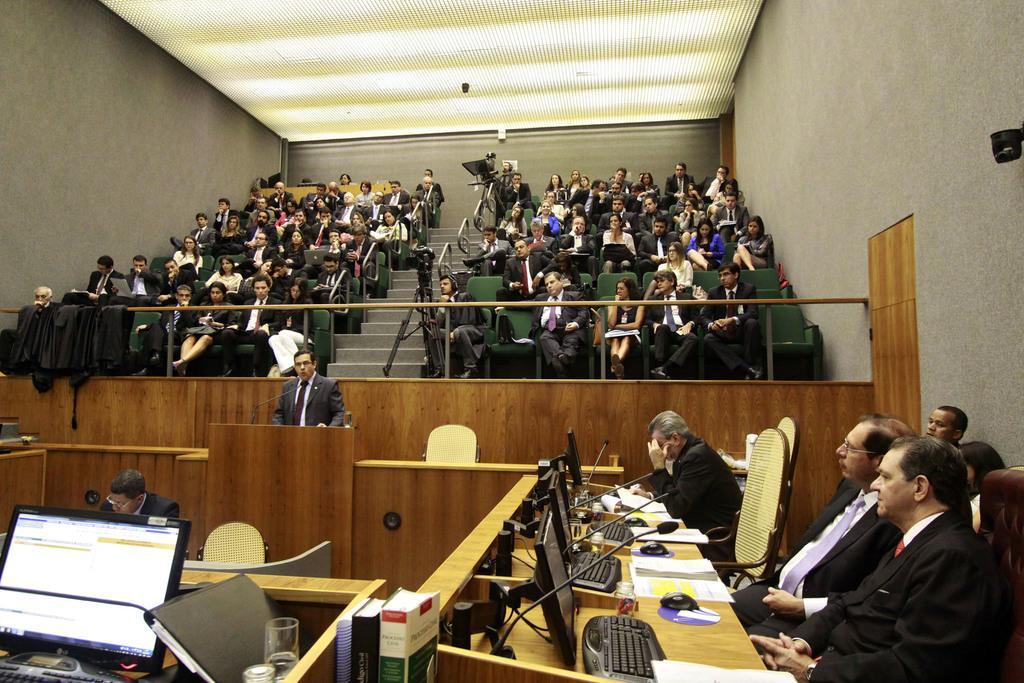Describe this image in one or two sentences. In this picture to the left, there is a computer on the table. A file and a glass on the table. In the middle, there is a person who is wearing a grey suit and is standing. To the right ,there are group of people who are sitting on the chair. There are group of people who are sitting on the chair at the top. There is a cameraman who is standing at the top. 